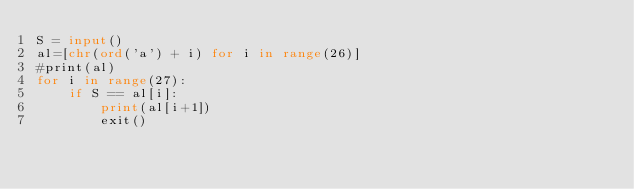Convert code to text. <code><loc_0><loc_0><loc_500><loc_500><_Python_>S = input()
al=[chr(ord('a') + i) for i in range(26)]
#print(al)
for i in range(27):
    if S == al[i]:
        print(al[i+1])
        exit()
</code> 